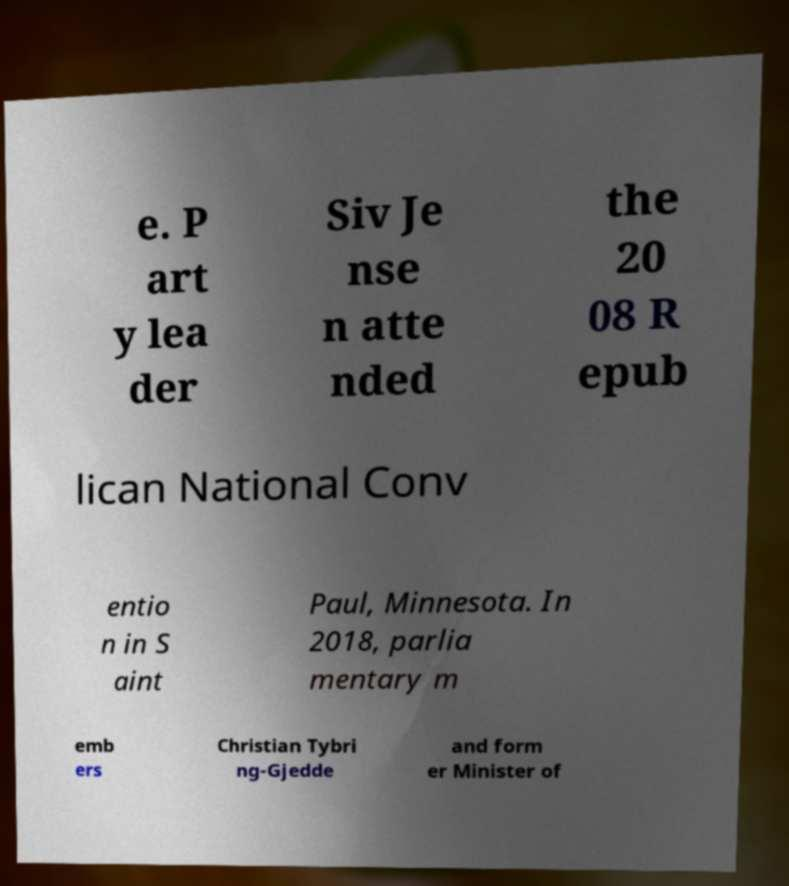Can you read and provide the text displayed in the image?This photo seems to have some interesting text. Can you extract and type it out for me? e. P art y lea der Siv Je nse n atte nded the 20 08 R epub lican National Conv entio n in S aint Paul, Minnesota. In 2018, parlia mentary m emb ers Christian Tybri ng-Gjedde and form er Minister of 